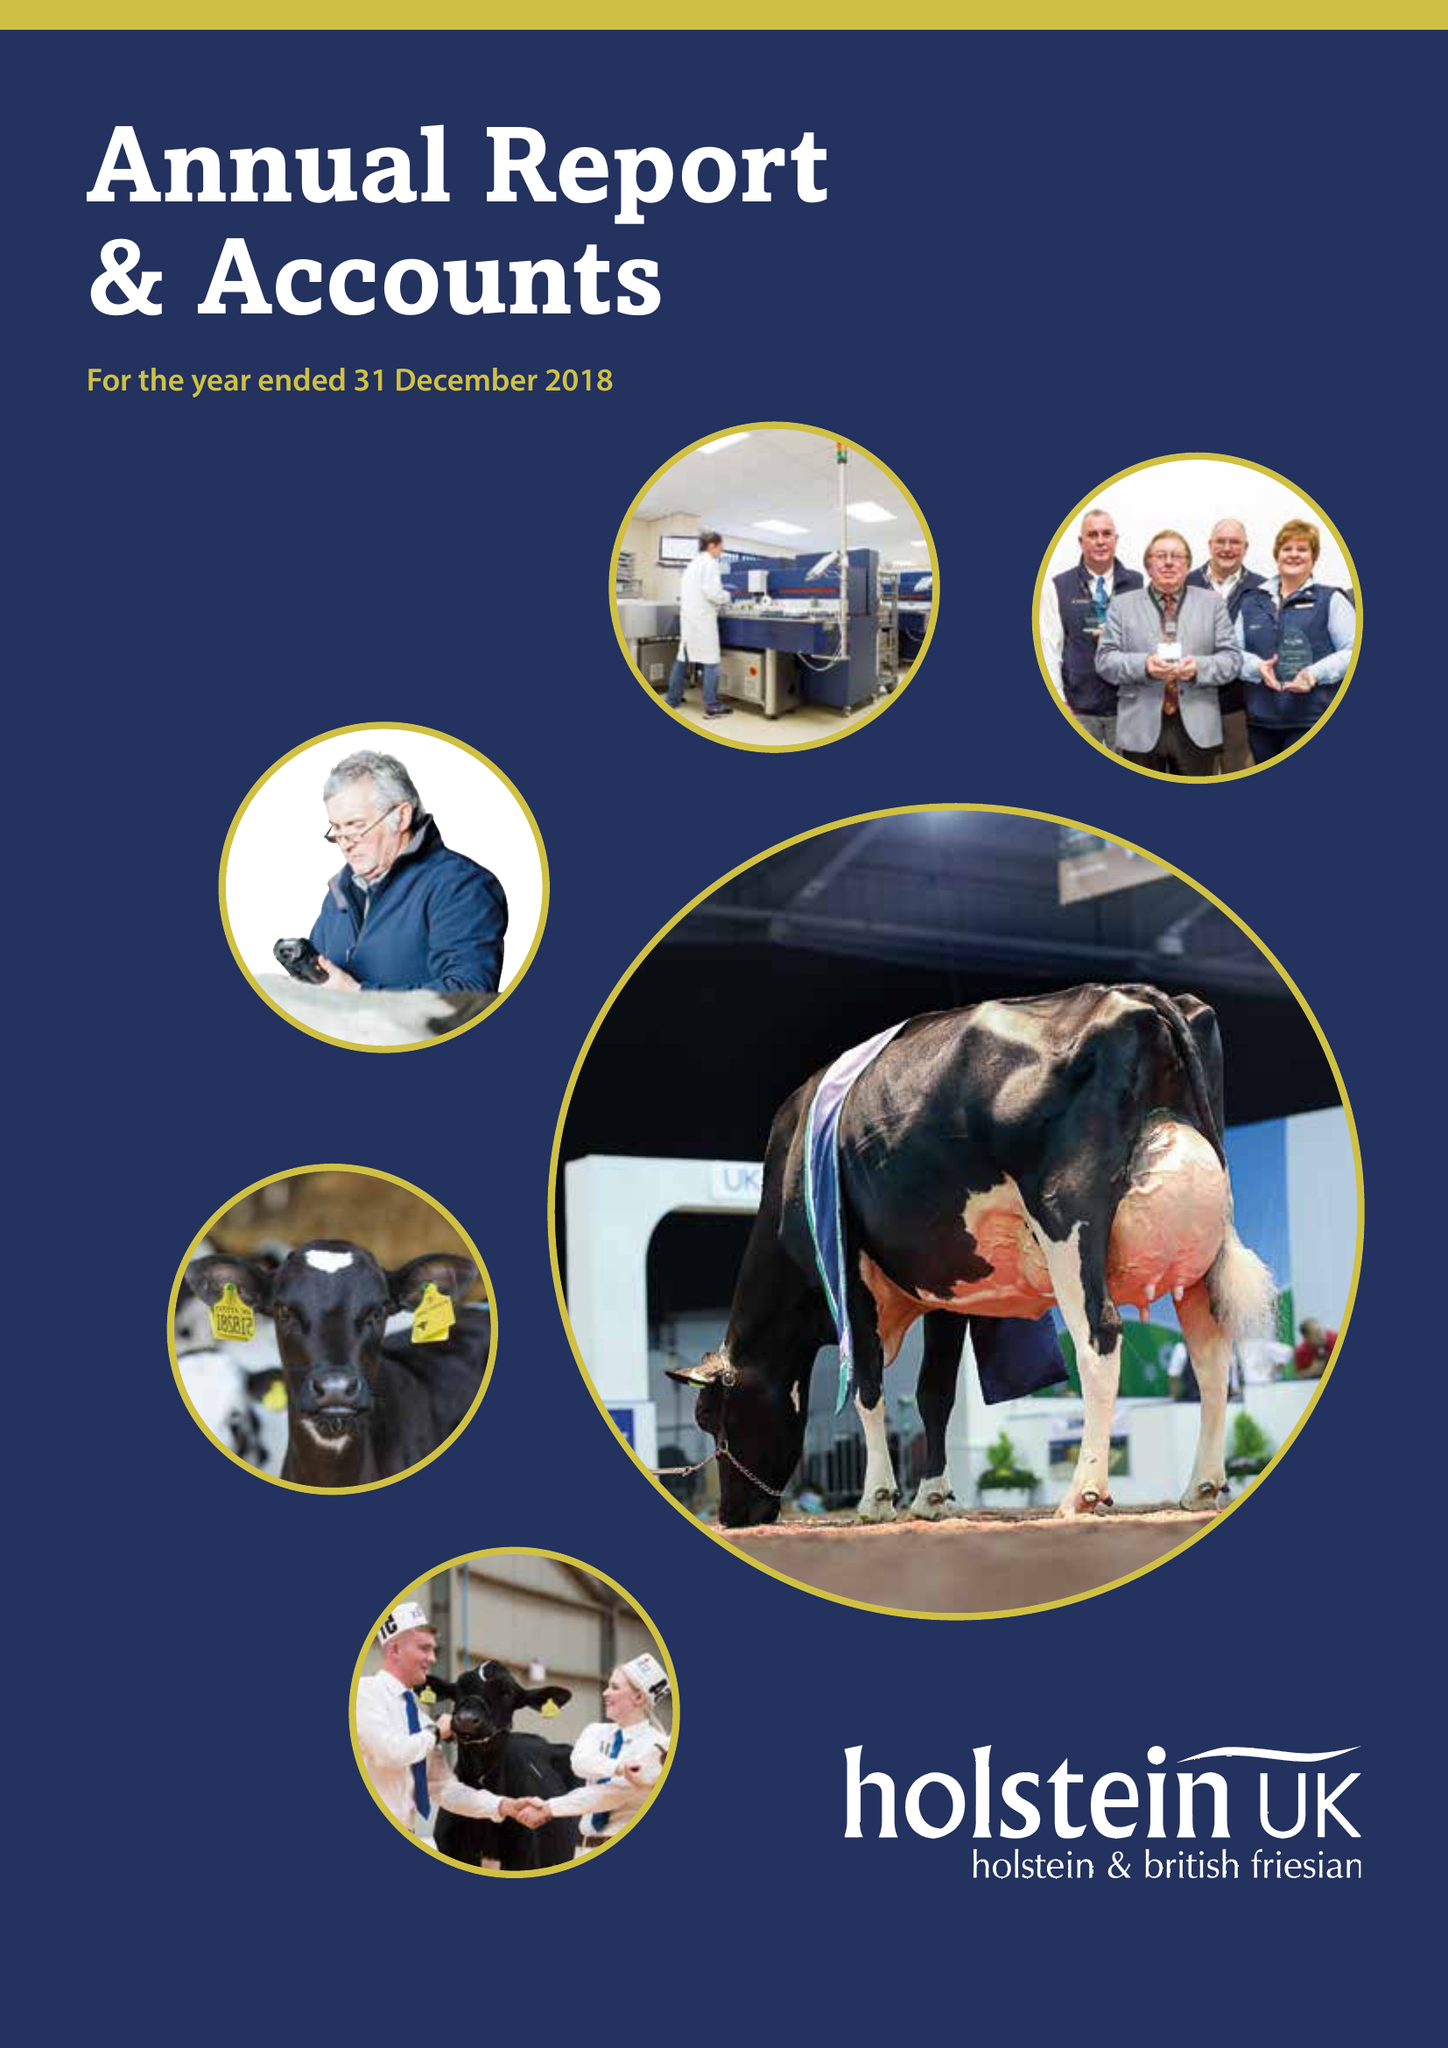What is the value for the address__postcode?
Answer the question using a single word or phrase. TF3 3BD 